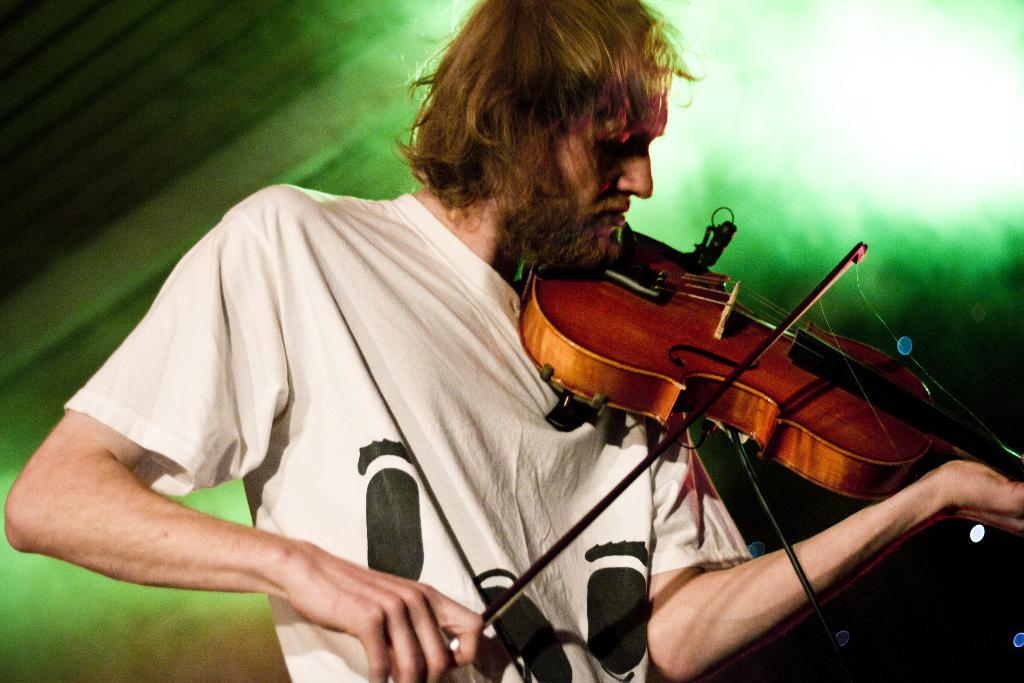Who is the person in the image? There is a man in the image. What is the man doing in the image? The man is playing the piano. What is the man holding in the image? The man is holding a piano. What color light can be seen in the background of the image? There is green color light in the background of the image. What type of plantation can be seen in the image? There is no plantation present in the image. How does the man pull the piano in the image? The man is not pulling the piano in the image; he is playing it. 